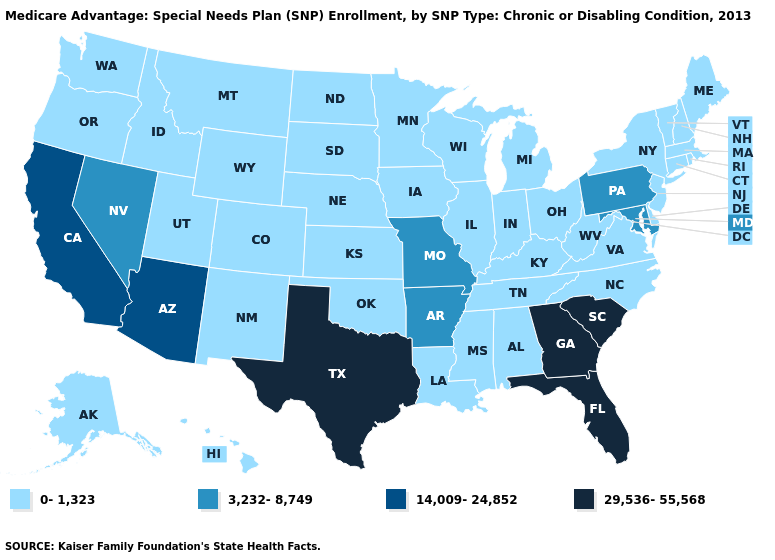What is the value of South Carolina?
Quick response, please. 29,536-55,568. Among the states that border Colorado , does Oklahoma have the lowest value?
Write a very short answer. Yes. Does Texas have the highest value in the USA?
Answer briefly. Yes. Does Idaho have the same value as Nevada?
Short answer required. No. Does Connecticut have the same value as Pennsylvania?
Answer briefly. No. What is the highest value in states that border Utah?
Concise answer only. 14,009-24,852. Does the first symbol in the legend represent the smallest category?
Quick response, please. Yes. Does the map have missing data?
Write a very short answer. No. Among the states that border Ohio , does Michigan have the highest value?
Concise answer only. No. What is the value of Washington?
Concise answer only. 0-1,323. Which states have the lowest value in the MidWest?
Short answer required. Iowa, Illinois, Indiana, Kansas, Michigan, Minnesota, North Dakota, Nebraska, Ohio, South Dakota, Wisconsin. Among the states that border Alabama , does Mississippi have the lowest value?
Give a very brief answer. Yes. Does Arizona have the lowest value in the USA?
Give a very brief answer. No. What is the value of Wisconsin?
Quick response, please. 0-1,323. Among the states that border Nebraska , which have the highest value?
Be succinct. Missouri. 